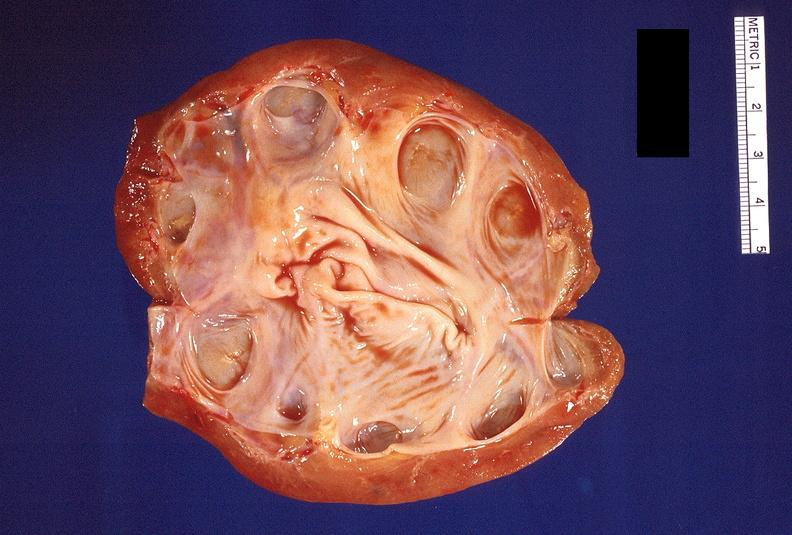does this image show hydronephrosis?
Answer the question using a single word or phrase. Yes 